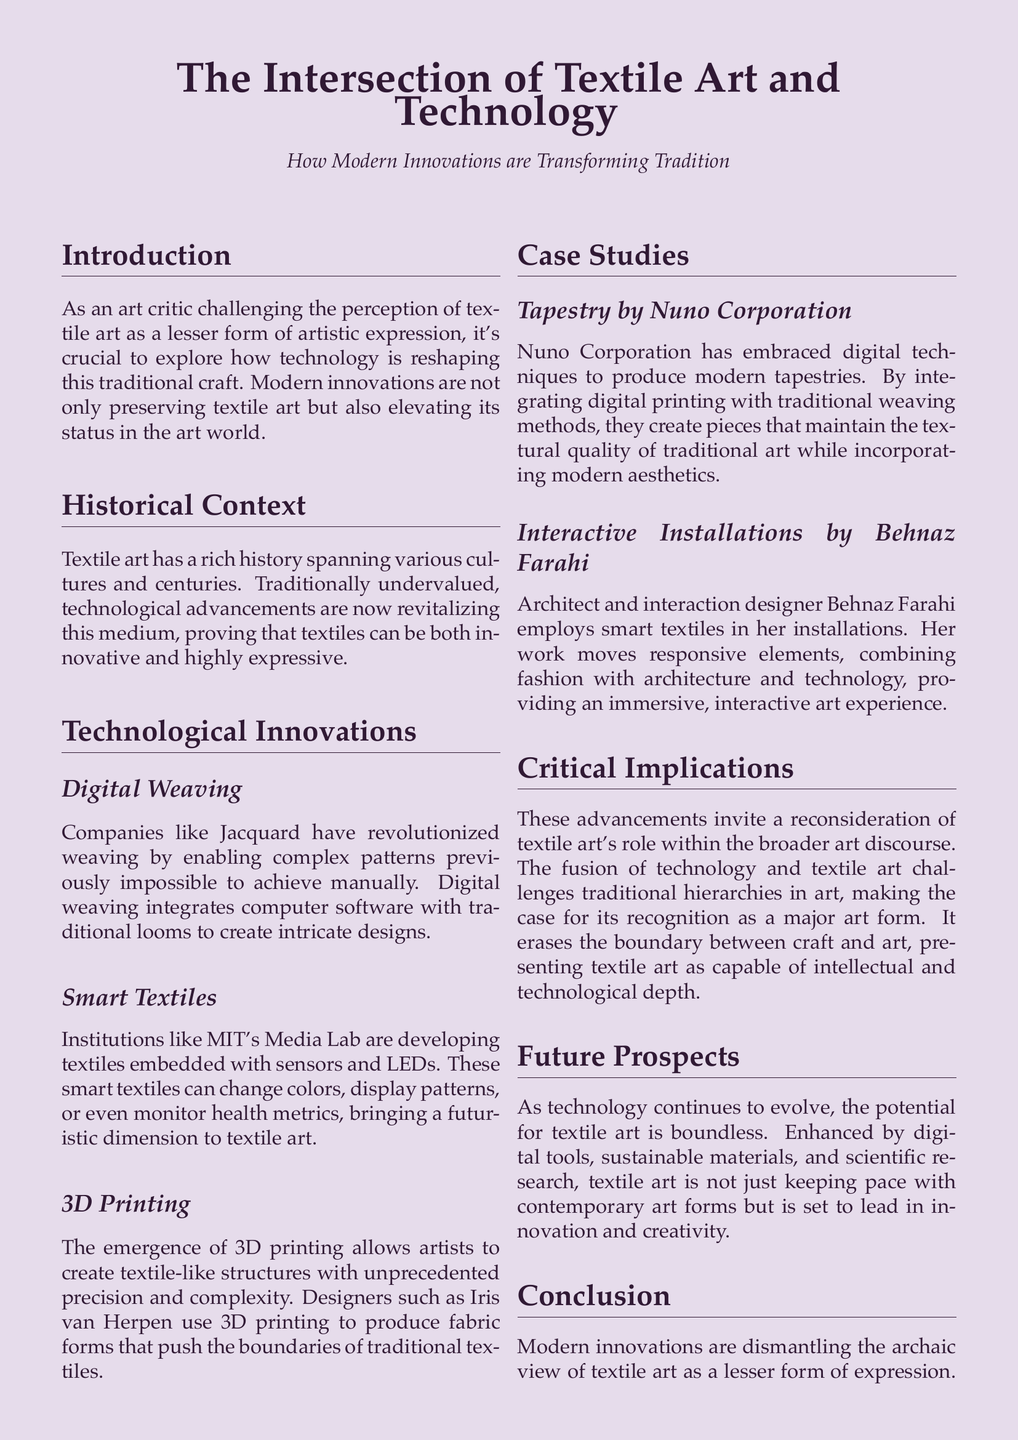What is the title of the case study? The title of the case study is stated at the beginning of the document.
Answer: The Intersection of Textile Art and Technology Who are the innovators mentioned in digital weaving? The innovators in digital weaving are mentioned in the context of companies that have revolutionized weaving techniques.
Answer: Jacquard What institution is developing smart textiles? The institution focused on smart textiles development is highlighted in the discussions of innovations.
Answer: MIT's Media Lab What does Behnaz Farahi combine in her installations? The combination of elements in Behnaz Farahi's installations is indicated in the case study section.
Answer: Fashion, architecture, and technology What potential does the document say exists for textile art as technology evolves? The document references the future possibilities for textile art in relation to technological advancements.
Answer: Boundless What is the primary argument for recognizing textile art in the document? The argument focuses on the transformative nature of textile art when combined with modern innovations.
Answer: Major art form Which designer is noted for using 3D printing in textile art? The designer identified for innovative use of 3D printing is mentioned alongside recognized figures in the field.
Answer: Iris van Herpen How does the document describe the relationship between tradition and technology in textile art? The relationship between tradition and technology in textile art is illustrated through the overall theme of the document.
Answer: Intricate dance 